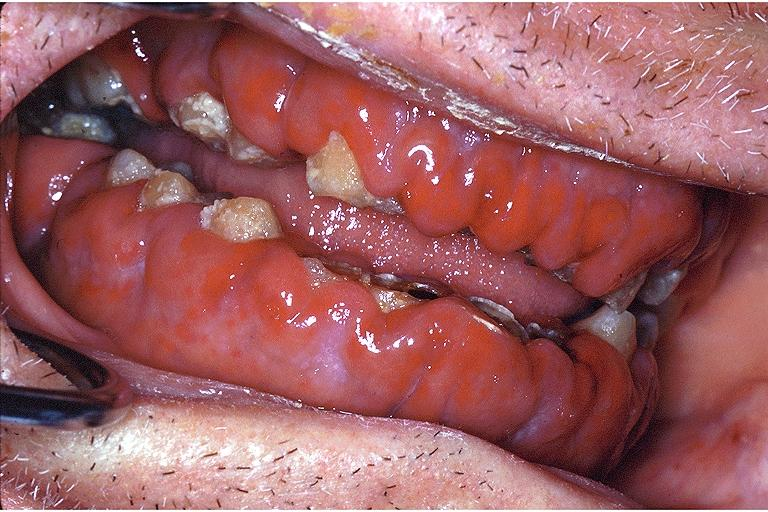where is this?
Answer the question using a single word or phrase. Oral 